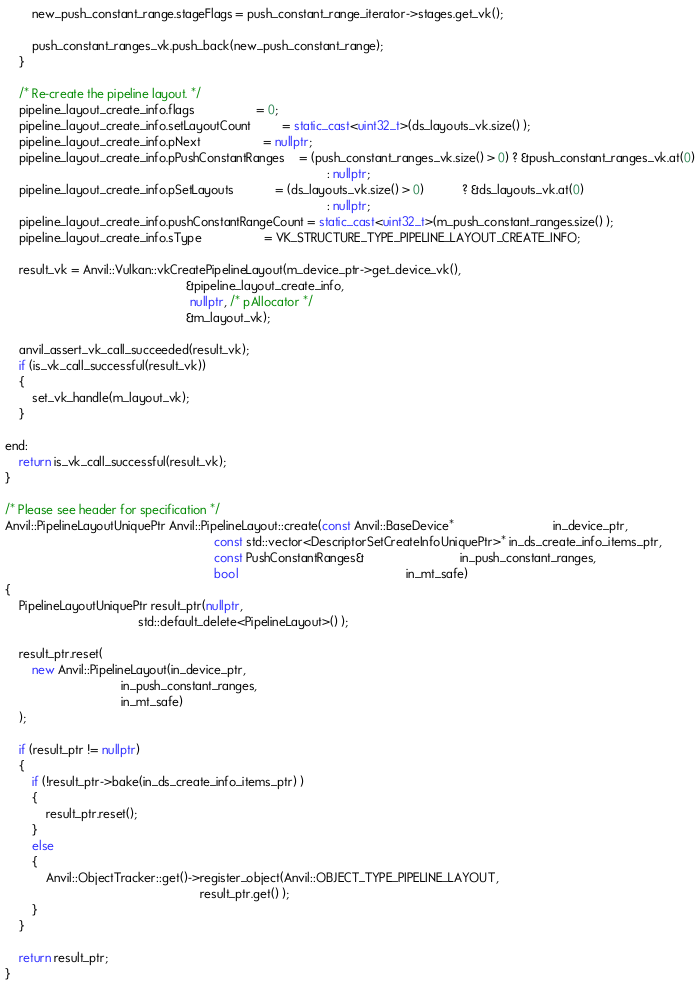<code> <loc_0><loc_0><loc_500><loc_500><_C++_>        new_push_constant_range.stageFlags = push_constant_range_iterator->stages.get_vk();

        push_constant_ranges_vk.push_back(new_push_constant_range);
    }

    /* Re-create the pipeline layout. */
    pipeline_layout_create_info.flags                  = 0;
    pipeline_layout_create_info.setLayoutCount         = static_cast<uint32_t>(ds_layouts_vk.size() );
    pipeline_layout_create_info.pNext                  = nullptr;
    pipeline_layout_create_info.pPushConstantRanges    = (push_constant_ranges_vk.size() > 0) ? &push_constant_ranges_vk.at(0)
                                                                                              : nullptr;
    pipeline_layout_create_info.pSetLayouts            = (ds_layouts_vk.size() > 0)           ? &ds_layouts_vk.at(0)
                                                                                              : nullptr;
    pipeline_layout_create_info.pushConstantRangeCount = static_cast<uint32_t>(m_push_constant_ranges.size() );
    pipeline_layout_create_info.sType                  = VK_STRUCTURE_TYPE_PIPELINE_LAYOUT_CREATE_INFO;

    result_vk = Anvil::Vulkan::vkCreatePipelineLayout(m_device_ptr->get_device_vk(),
                                                     &pipeline_layout_create_info,
                                                      nullptr, /* pAllocator */
                                                     &m_layout_vk);

    anvil_assert_vk_call_succeeded(result_vk);
    if (is_vk_call_successful(result_vk))
    {
        set_vk_handle(m_layout_vk);
    }

end:
    return is_vk_call_successful(result_vk);
}

/* Please see header for specification */
Anvil::PipelineLayoutUniquePtr Anvil::PipelineLayout::create(const Anvil::BaseDevice*                             in_device_ptr,
                                                             const std::vector<DescriptorSetCreateInfoUniquePtr>* in_ds_create_info_items_ptr,
                                                             const PushConstantRanges&                            in_push_constant_ranges,
                                                             bool                                                 in_mt_safe)
{
    PipelineLayoutUniquePtr result_ptr(nullptr,
                                       std::default_delete<PipelineLayout>() );

    result_ptr.reset(
        new Anvil::PipelineLayout(in_device_ptr,
                                  in_push_constant_ranges,
                                  in_mt_safe)
    );

    if (result_ptr != nullptr)
    {
        if (!result_ptr->bake(in_ds_create_info_items_ptr) )
        {
            result_ptr.reset();
        }
        else
        {
            Anvil::ObjectTracker::get()->register_object(Anvil::OBJECT_TYPE_PIPELINE_LAYOUT,
                                                         result_ptr.get() );
        }
    }

    return result_ptr;
}

</code> 